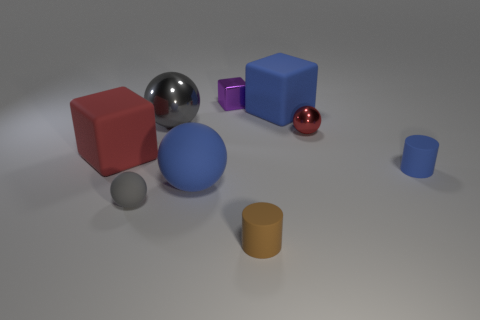Subtract all cubes. How many objects are left? 6 Subtract all large blue matte balls. Subtract all purple metal things. How many objects are left? 7 Add 7 gray rubber spheres. How many gray rubber spheres are left? 8 Add 2 tiny red shiny blocks. How many tiny red shiny blocks exist? 2 Subtract 0 yellow cubes. How many objects are left? 9 